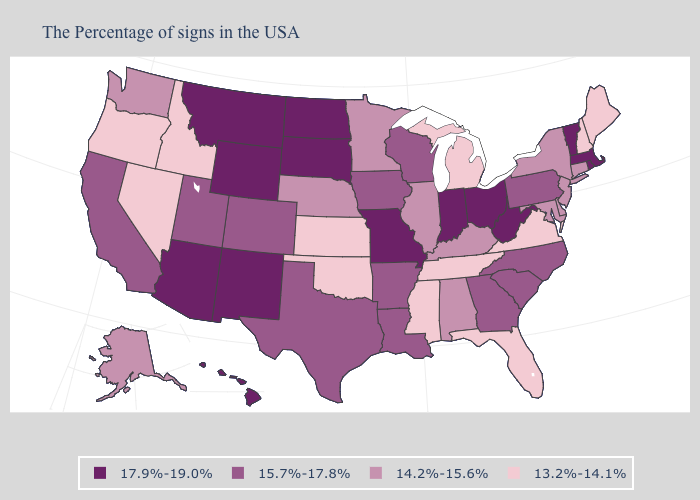Which states have the lowest value in the USA?
Give a very brief answer. Maine, New Hampshire, Virginia, Florida, Michigan, Tennessee, Mississippi, Kansas, Oklahoma, Idaho, Nevada, Oregon. Name the states that have a value in the range 14.2%-15.6%?
Write a very short answer. Connecticut, New York, New Jersey, Delaware, Maryland, Kentucky, Alabama, Illinois, Minnesota, Nebraska, Washington, Alaska. What is the highest value in the West ?
Write a very short answer. 17.9%-19.0%. Does Nevada have the lowest value in the USA?
Keep it brief. Yes. How many symbols are there in the legend?
Concise answer only. 4. Does West Virginia have the lowest value in the South?
Write a very short answer. No. What is the value of Vermont?
Short answer required. 17.9%-19.0%. What is the value of Wyoming?
Give a very brief answer. 17.9%-19.0%. Name the states that have a value in the range 17.9%-19.0%?
Give a very brief answer. Massachusetts, Rhode Island, Vermont, West Virginia, Ohio, Indiana, Missouri, South Dakota, North Dakota, Wyoming, New Mexico, Montana, Arizona, Hawaii. What is the lowest value in the USA?
Answer briefly. 13.2%-14.1%. Among the states that border North Dakota , does South Dakota have the highest value?
Quick response, please. Yes. What is the value of Utah?
Short answer required. 15.7%-17.8%. What is the value of Arizona?
Answer briefly. 17.9%-19.0%. Does the map have missing data?
Concise answer only. No. Which states have the lowest value in the MidWest?
Keep it brief. Michigan, Kansas. 